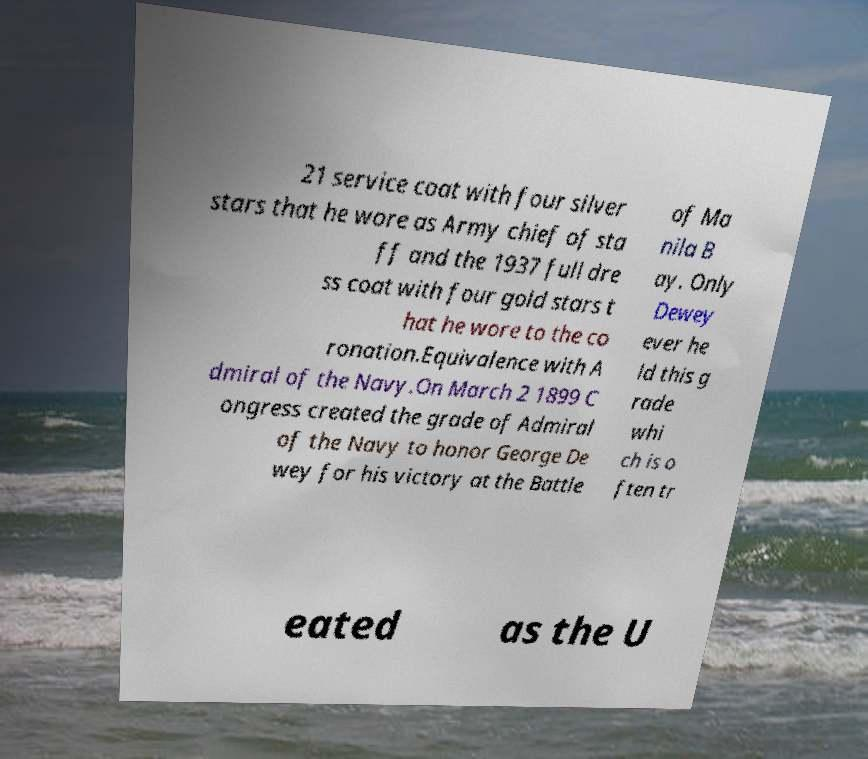For documentation purposes, I need the text within this image transcribed. Could you provide that? 21 service coat with four silver stars that he wore as Army chief of sta ff and the 1937 full dre ss coat with four gold stars t hat he wore to the co ronation.Equivalence with A dmiral of the Navy.On March 2 1899 C ongress created the grade of Admiral of the Navy to honor George De wey for his victory at the Battle of Ma nila B ay. Only Dewey ever he ld this g rade whi ch is o ften tr eated as the U 